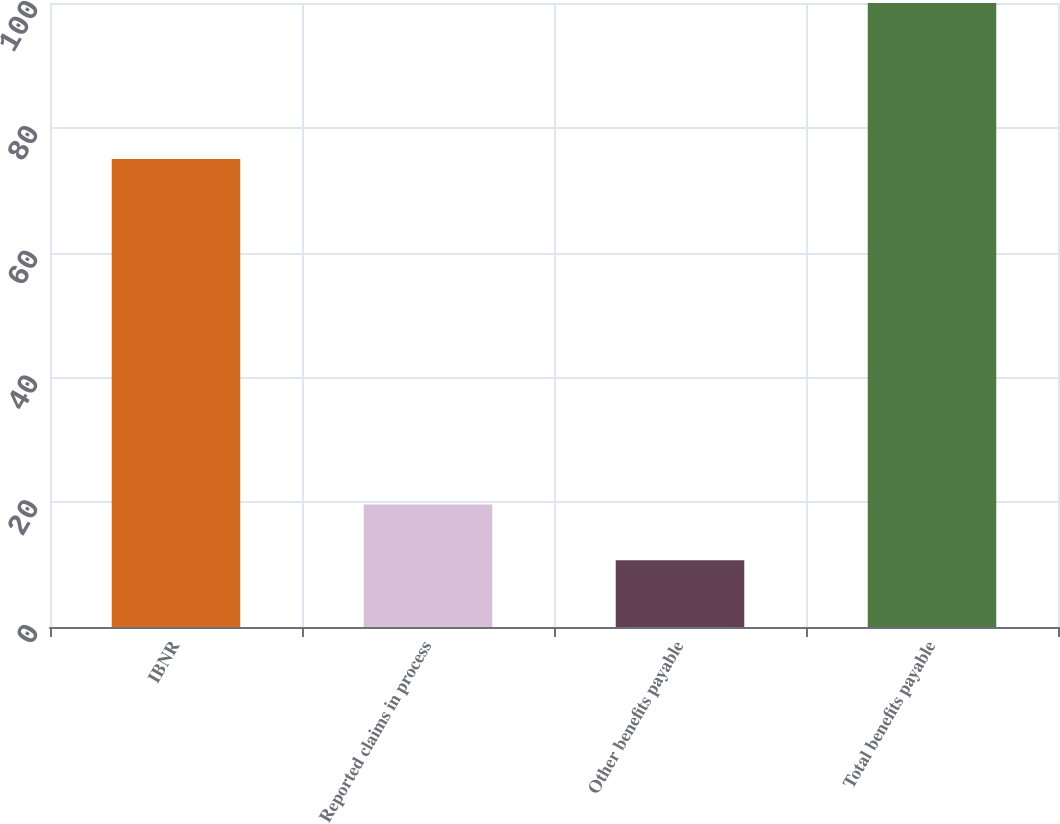<chart> <loc_0><loc_0><loc_500><loc_500><bar_chart><fcel>IBNR<fcel>Reported claims in process<fcel>Other benefits payable<fcel>Total benefits payable<nl><fcel>75<fcel>19.63<fcel>10.7<fcel>100<nl></chart> 